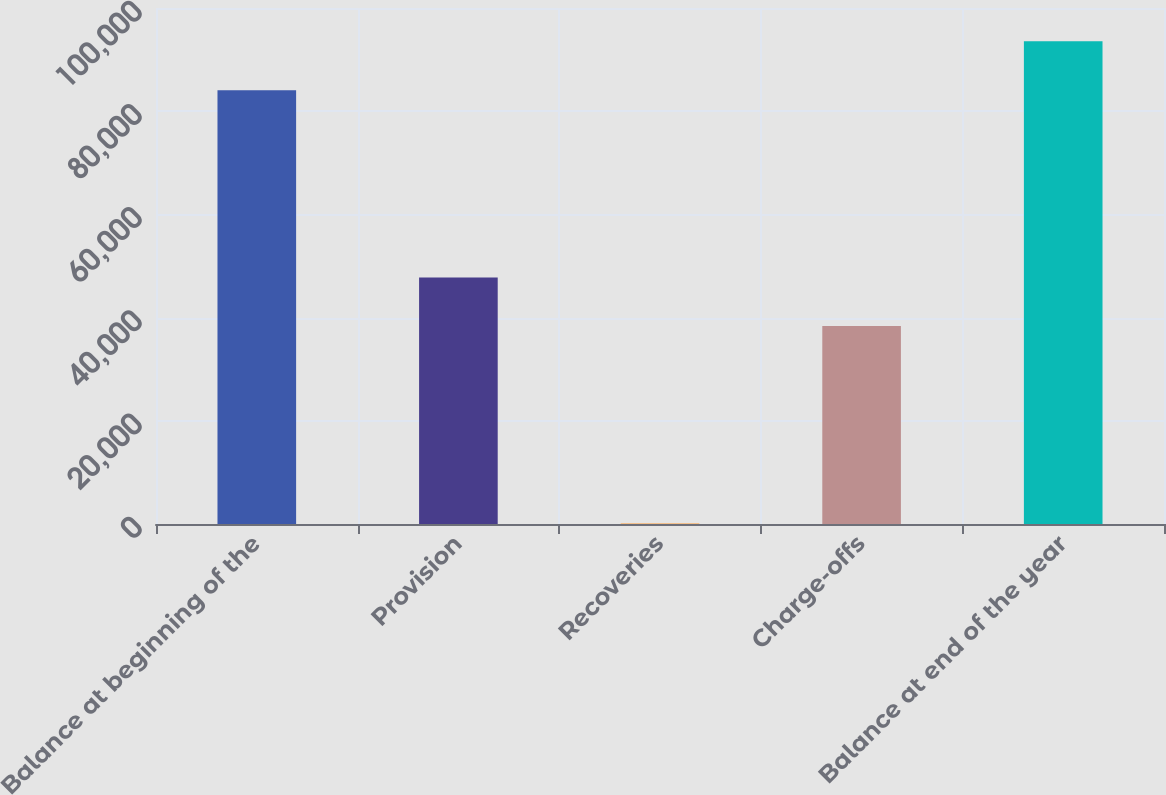<chart> <loc_0><loc_0><loc_500><loc_500><bar_chart><fcel>Balance at beginning of the<fcel>Provision<fcel>Recoveries<fcel>Charge-offs<fcel>Balance at end of the year<nl><fcel>84073<fcel>47750<fcel>88<fcel>38376<fcel>93535<nl></chart> 